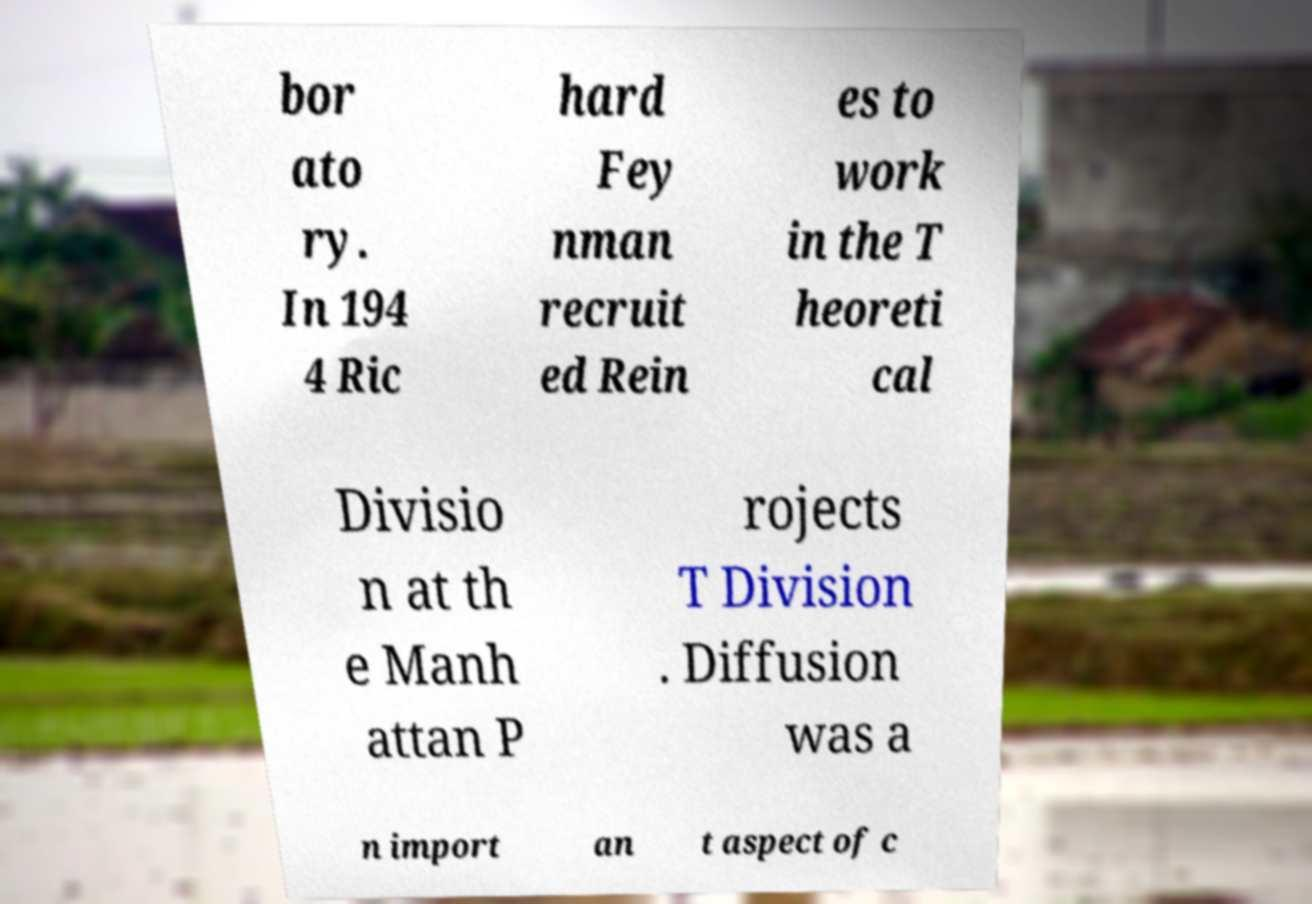Please read and relay the text visible in this image. What does it say? bor ato ry. In 194 4 Ric hard Fey nman recruit ed Rein es to work in the T heoreti cal Divisio n at th e Manh attan P rojects T Division . Diffusion was a n import an t aspect of c 